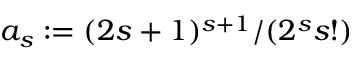<formula> <loc_0><loc_0><loc_500><loc_500>a _ { s } \colon = ( 2 s + 1 ) ^ { s + 1 } / ( 2 ^ { s } s ! )</formula> 